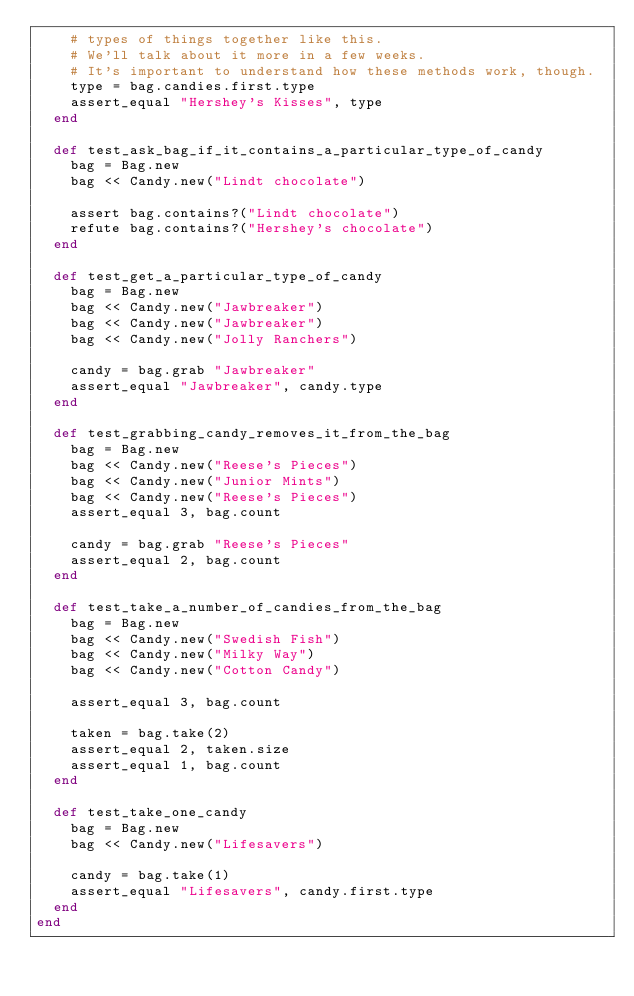Convert code to text. <code><loc_0><loc_0><loc_500><loc_500><_Ruby_>    # types of things together like this.
    # We'll talk about it more in a few weeks.
    # It's important to understand how these methods work, though.
    type = bag.candies.first.type
    assert_equal "Hershey's Kisses", type
  end

  def test_ask_bag_if_it_contains_a_particular_type_of_candy
    bag = Bag.new
    bag << Candy.new("Lindt chocolate")

    assert bag.contains?("Lindt chocolate")
    refute bag.contains?("Hershey's chocolate")
  end

  def test_get_a_particular_type_of_candy
    bag = Bag.new
    bag << Candy.new("Jawbreaker")
    bag << Candy.new("Jawbreaker")
    bag << Candy.new("Jolly Ranchers")

    candy = bag.grab "Jawbreaker"
    assert_equal "Jawbreaker", candy.type
  end

  def test_grabbing_candy_removes_it_from_the_bag
    bag = Bag.new
    bag << Candy.new("Reese's Pieces")
    bag << Candy.new("Junior Mints")
    bag << Candy.new("Reese's Pieces")
    assert_equal 3, bag.count

    candy = bag.grab "Reese's Pieces"
    assert_equal 2, bag.count
  end

  def test_take_a_number_of_candies_from_the_bag
    bag = Bag.new
    bag << Candy.new("Swedish Fish")
    bag << Candy.new("Milky Way")
    bag << Candy.new("Cotton Candy")

    assert_equal 3, bag.count

    taken = bag.take(2)
    assert_equal 2, taken.size
    assert_equal 1, bag.count
  end

  def test_take_one_candy
    bag = Bag.new
    bag << Candy.new("Lifesavers")

    candy = bag.take(1)
    assert_equal "Lifesavers", candy.first.type
  end
end

</code> 